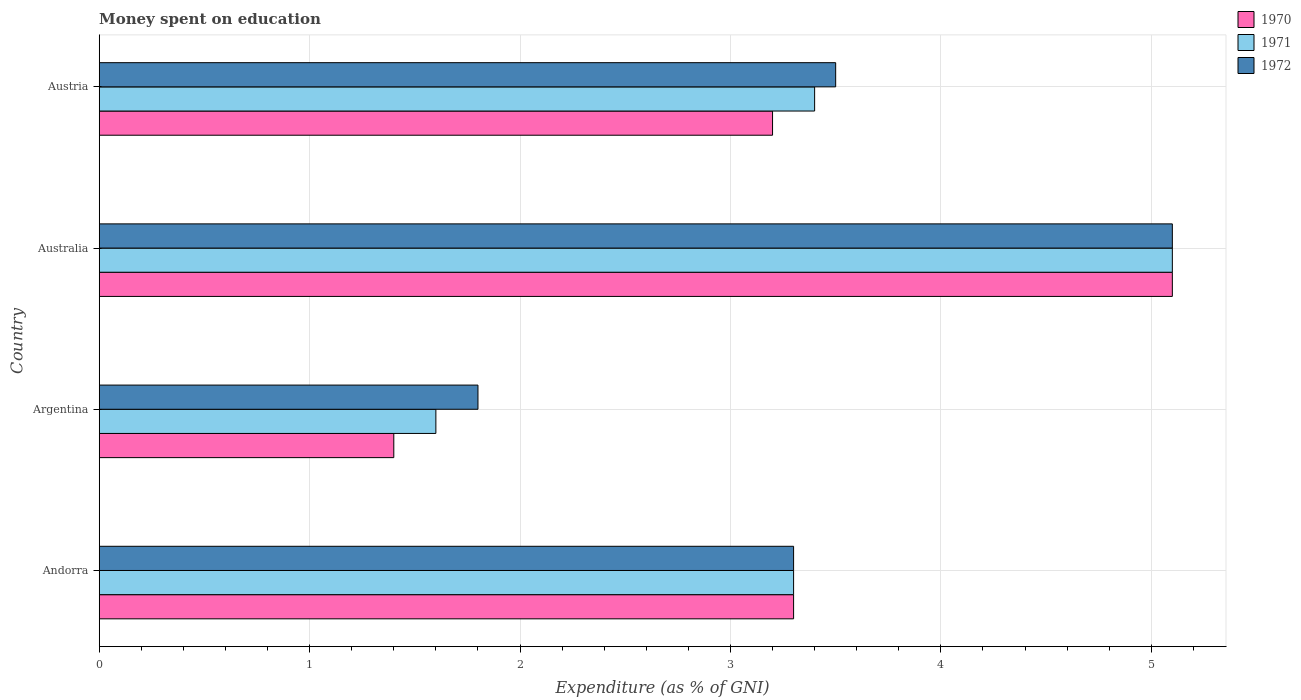How many bars are there on the 4th tick from the bottom?
Your response must be concise. 3. What is the label of the 3rd group of bars from the top?
Your response must be concise. Argentina. In how many cases, is the number of bars for a given country not equal to the number of legend labels?
Your answer should be compact. 0. What is the amount of money spent on education in 1971 in Andorra?
Provide a short and direct response. 3.3. Across all countries, what is the maximum amount of money spent on education in 1972?
Ensure brevity in your answer.  5.1. Across all countries, what is the minimum amount of money spent on education in 1971?
Your answer should be compact. 1.6. What is the difference between the amount of money spent on education in 1972 in Argentina and the amount of money spent on education in 1971 in Andorra?
Offer a very short reply. -1.5. What is the difference between the amount of money spent on education in 1971 and amount of money spent on education in 1972 in Austria?
Make the answer very short. -0.1. In how many countries, is the amount of money spent on education in 1972 greater than 1.8 %?
Keep it short and to the point. 3. What is the ratio of the amount of money spent on education in 1970 in Argentina to that in Austria?
Your answer should be compact. 0.44. What is the difference between the highest and the second highest amount of money spent on education in 1970?
Keep it short and to the point. 1.8. What is the difference between the highest and the lowest amount of money spent on education in 1970?
Keep it short and to the point. 3.7. What does the 2nd bar from the bottom in Austria represents?
Make the answer very short. 1971. How many bars are there?
Offer a terse response. 12. How many countries are there in the graph?
Your response must be concise. 4. What is the difference between two consecutive major ticks on the X-axis?
Provide a short and direct response. 1. Are the values on the major ticks of X-axis written in scientific E-notation?
Your response must be concise. No. Does the graph contain any zero values?
Make the answer very short. No. Does the graph contain grids?
Your answer should be very brief. Yes. Where does the legend appear in the graph?
Give a very brief answer. Top right. How many legend labels are there?
Keep it short and to the point. 3. What is the title of the graph?
Provide a short and direct response. Money spent on education. Does "1986" appear as one of the legend labels in the graph?
Offer a terse response. No. What is the label or title of the X-axis?
Keep it short and to the point. Expenditure (as % of GNI). What is the label or title of the Y-axis?
Give a very brief answer. Country. What is the Expenditure (as % of GNI) in 1970 in Andorra?
Your response must be concise. 3.3. What is the Expenditure (as % of GNI) in 1971 in Andorra?
Your response must be concise. 3.3. What is the Expenditure (as % of GNI) of 1972 in Andorra?
Your answer should be very brief. 3.3. What is the Expenditure (as % of GNI) of 1970 in Australia?
Ensure brevity in your answer.  5.1. What is the Expenditure (as % of GNI) of 1972 in Australia?
Offer a very short reply. 5.1. What is the Expenditure (as % of GNI) of 1972 in Austria?
Provide a succinct answer. 3.5. Across all countries, what is the maximum Expenditure (as % of GNI) in 1971?
Offer a very short reply. 5.1. Across all countries, what is the maximum Expenditure (as % of GNI) of 1972?
Keep it short and to the point. 5.1. Across all countries, what is the minimum Expenditure (as % of GNI) of 1970?
Provide a short and direct response. 1.4. What is the total Expenditure (as % of GNI) of 1970 in the graph?
Your response must be concise. 13. What is the difference between the Expenditure (as % of GNI) of 1971 in Andorra and that in Argentina?
Your answer should be very brief. 1.7. What is the difference between the Expenditure (as % of GNI) of 1972 in Andorra and that in Australia?
Offer a terse response. -1.8. What is the difference between the Expenditure (as % of GNI) in 1970 in Andorra and that in Austria?
Offer a very short reply. 0.1. What is the difference between the Expenditure (as % of GNI) in 1972 in Andorra and that in Austria?
Your answer should be compact. -0.2. What is the difference between the Expenditure (as % of GNI) in 1970 in Argentina and that in Australia?
Offer a very short reply. -3.7. What is the difference between the Expenditure (as % of GNI) of 1971 in Argentina and that in Australia?
Offer a terse response. -3.5. What is the difference between the Expenditure (as % of GNI) of 1971 in Australia and that in Austria?
Your response must be concise. 1.7. What is the difference between the Expenditure (as % of GNI) of 1970 in Andorra and the Expenditure (as % of GNI) of 1972 in Austria?
Give a very brief answer. -0.2. What is the difference between the Expenditure (as % of GNI) in 1971 in Andorra and the Expenditure (as % of GNI) in 1972 in Austria?
Your answer should be very brief. -0.2. What is the difference between the Expenditure (as % of GNI) of 1971 in Argentina and the Expenditure (as % of GNI) of 1972 in Austria?
Your response must be concise. -1.9. What is the difference between the Expenditure (as % of GNI) of 1970 in Australia and the Expenditure (as % of GNI) of 1971 in Austria?
Make the answer very short. 1.7. What is the difference between the Expenditure (as % of GNI) in 1971 in Australia and the Expenditure (as % of GNI) in 1972 in Austria?
Make the answer very short. 1.6. What is the average Expenditure (as % of GNI) of 1971 per country?
Your response must be concise. 3.35. What is the average Expenditure (as % of GNI) of 1972 per country?
Provide a short and direct response. 3.42. What is the difference between the Expenditure (as % of GNI) of 1970 and Expenditure (as % of GNI) of 1972 in Argentina?
Your answer should be compact. -0.4. What is the difference between the Expenditure (as % of GNI) of 1970 and Expenditure (as % of GNI) of 1971 in Australia?
Your answer should be compact. 0. What is the difference between the Expenditure (as % of GNI) in 1970 and Expenditure (as % of GNI) in 1971 in Austria?
Your response must be concise. -0.2. What is the difference between the Expenditure (as % of GNI) of 1970 and Expenditure (as % of GNI) of 1972 in Austria?
Give a very brief answer. -0.3. What is the ratio of the Expenditure (as % of GNI) in 1970 in Andorra to that in Argentina?
Give a very brief answer. 2.36. What is the ratio of the Expenditure (as % of GNI) in 1971 in Andorra to that in Argentina?
Keep it short and to the point. 2.06. What is the ratio of the Expenditure (as % of GNI) of 1972 in Andorra to that in Argentina?
Keep it short and to the point. 1.83. What is the ratio of the Expenditure (as % of GNI) in 1970 in Andorra to that in Australia?
Make the answer very short. 0.65. What is the ratio of the Expenditure (as % of GNI) of 1971 in Andorra to that in Australia?
Make the answer very short. 0.65. What is the ratio of the Expenditure (as % of GNI) in 1972 in Andorra to that in Australia?
Your response must be concise. 0.65. What is the ratio of the Expenditure (as % of GNI) of 1970 in Andorra to that in Austria?
Ensure brevity in your answer.  1.03. What is the ratio of the Expenditure (as % of GNI) of 1971 in Andorra to that in Austria?
Offer a very short reply. 0.97. What is the ratio of the Expenditure (as % of GNI) of 1972 in Andorra to that in Austria?
Make the answer very short. 0.94. What is the ratio of the Expenditure (as % of GNI) in 1970 in Argentina to that in Australia?
Give a very brief answer. 0.27. What is the ratio of the Expenditure (as % of GNI) of 1971 in Argentina to that in Australia?
Offer a terse response. 0.31. What is the ratio of the Expenditure (as % of GNI) of 1972 in Argentina to that in Australia?
Provide a succinct answer. 0.35. What is the ratio of the Expenditure (as % of GNI) in 1970 in Argentina to that in Austria?
Your answer should be compact. 0.44. What is the ratio of the Expenditure (as % of GNI) of 1971 in Argentina to that in Austria?
Your answer should be very brief. 0.47. What is the ratio of the Expenditure (as % of GNI) in 1972 in Argentina to that in Austria?
Provide a succinct answer. 0.51. What is the ratio of the Expenditure (as % of GNI) of 1970 in Australia to that in Austria?
Offer a very short reply. 1.59. What is the ratio of the Expenditure (as % of GNI) in 1971 in Australia to that in Austria?
Keep it short and to the point. 1.5. What is the ratio of the Expenditure (as % of GNI) in 1972 in Australia to that in Austria?
Provide a succinct answer. 1.46. What is the difference between the highest and the second highest Expenditure (as % of GNI) in 1971?
Your response must be concise. 1.7. What is the difference between the highest and the lowest Expenditure (as % of GNI) in 1971?
Provide a short and direct response. 3.5. 